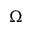Convert formula to latex. <formula><loc_0><loc_0><loc_500><loc_500>\Omega</formula> 